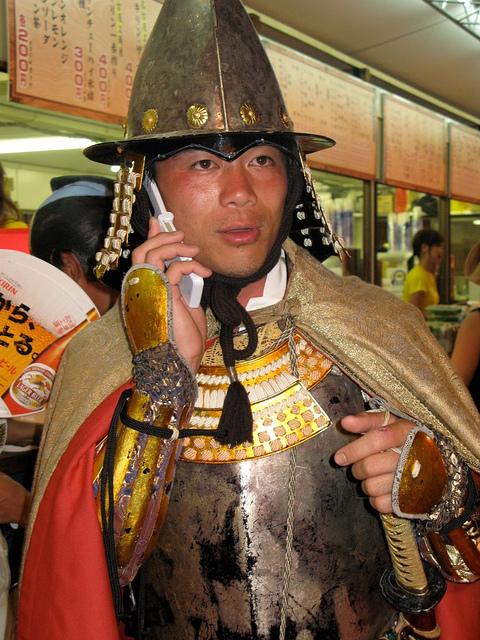What is on his head?
Give a very brief answer. Helmet. Is he using a landline phone?
Quick response, please. No. Is he dressed up?
Keep it brief. Yes. 